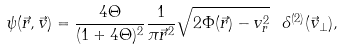<formula> <loc_0><loc_0><loc_500><loc_500>\psi ( \vec { r } , \vec { v } ) = \frac { 4 \Theta } { ( 1 + 4 \Theta ) ^ { 2 } } \frac { 1 } { \pi \vec { r } ^ { 2 } } \sqrt { 2 \Phi ( \vec { r } ) - v _ { r } ^ { 2 } } \ \delta ^ { ( 2 ) } ( \vec { v } _ { \perp } ) ,</formula> 